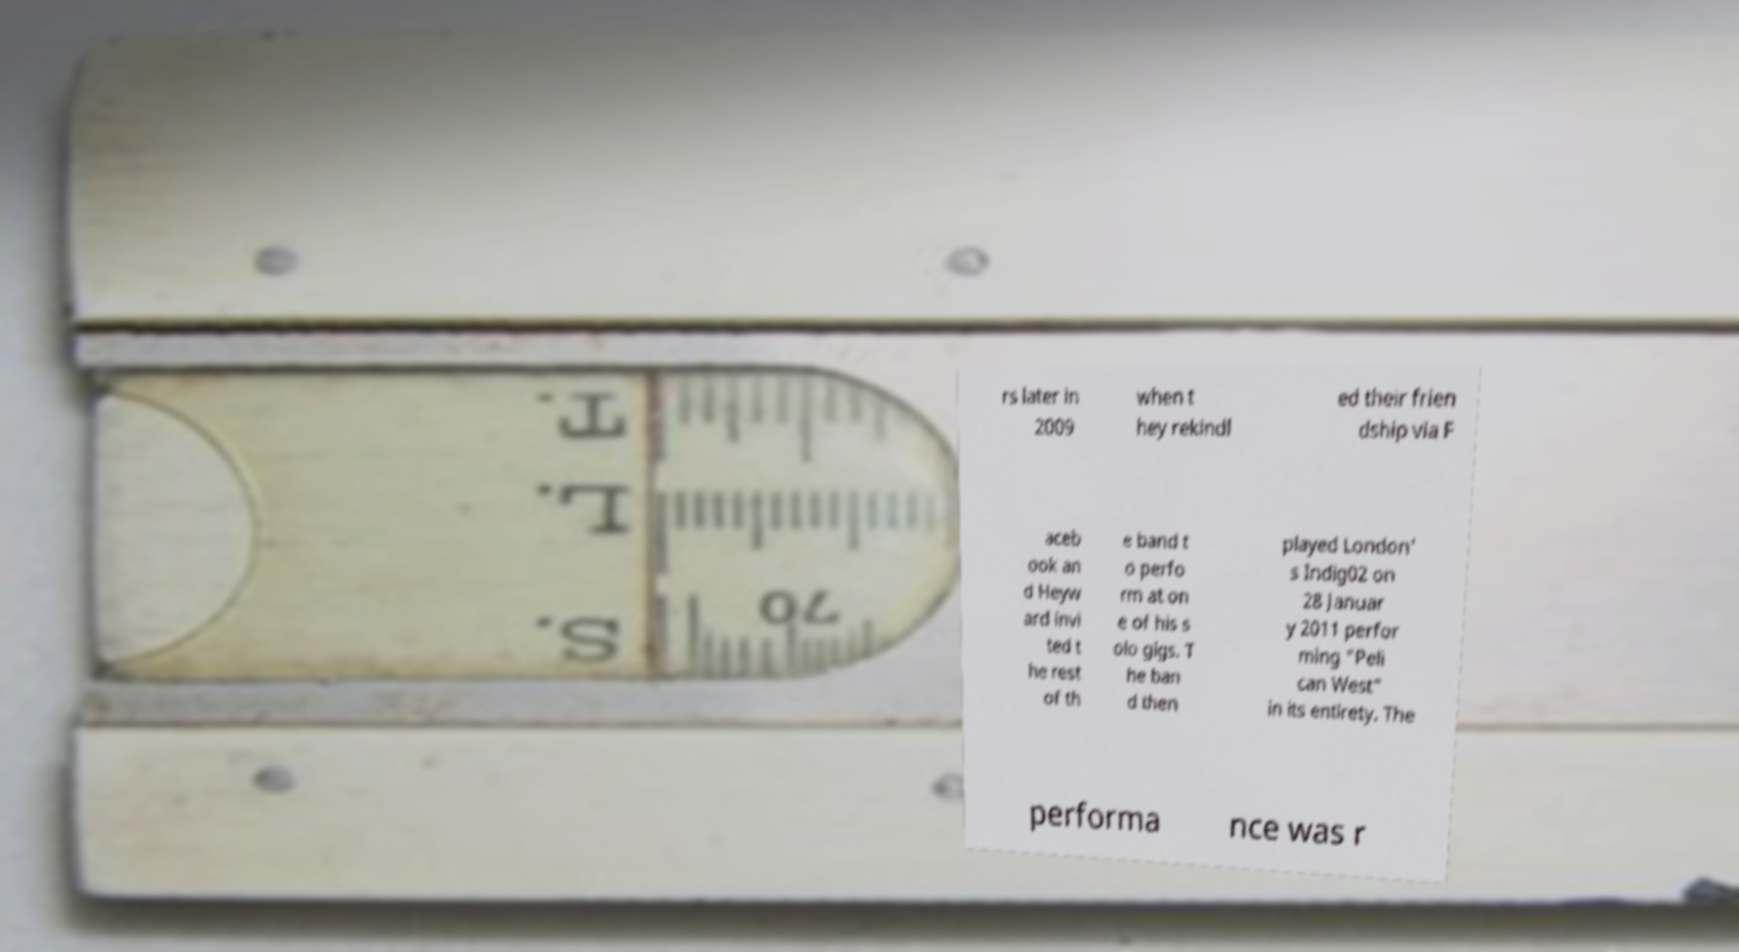I need the written content from this picture converted into text. Can you do that? rs later in 2009 when t hey rekindl ed their frien dship via F aceb ook an d Heyw ard invi ted t he rest of th e band t o perfo rm at on e of his s olo gigs. T he ban d then played London' s Indig02 on 28 Januar y 2011 perfor ming "Peli can West" in its entirety. The performa nce was r 